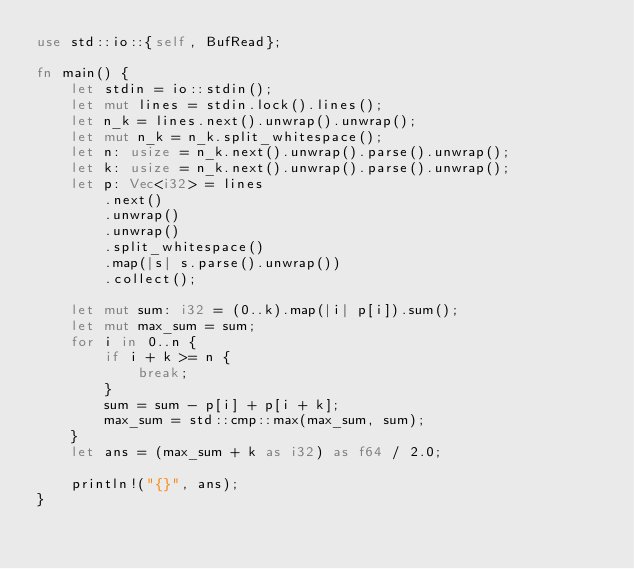<code> <loc_0><loc_0><loc_500><loc_500><_Rust_>use std::io::{self, BufRead};

fn main() {
    let stdin = io::stdin();
    let mut lines = stdin.lock().lines();
    let n_k = lines.next().unwrap().unwrap();
    let mut n_k = n_k.split_whitespace();
    let n: usize = n_k.next().unwrap().parse().unwrap();
    let k: usize = n_k.next().unwrap().parse().unwrap();
    let p: Vec<i32> = lines
        .next()
        .unwrap()
        .unwrap()
        .split_whitespace()
        .map(|s| s.parse().unwrap())
        .collect();

    let mut sum: i32 = (0..k).map(|i| p[i]).sum();
    let mut max_sum = sum;
    for i in 0..n {
        if i + k >= n {
            break;
        }
        sum = sum - p[i] + p[i + k];
        max_sum = std::cmp::max(max_sum, sum);
    }
    let ans = (max_sum + k as i32) as f64 / 2.0;

    println!("{}", ans);
}
</code> 